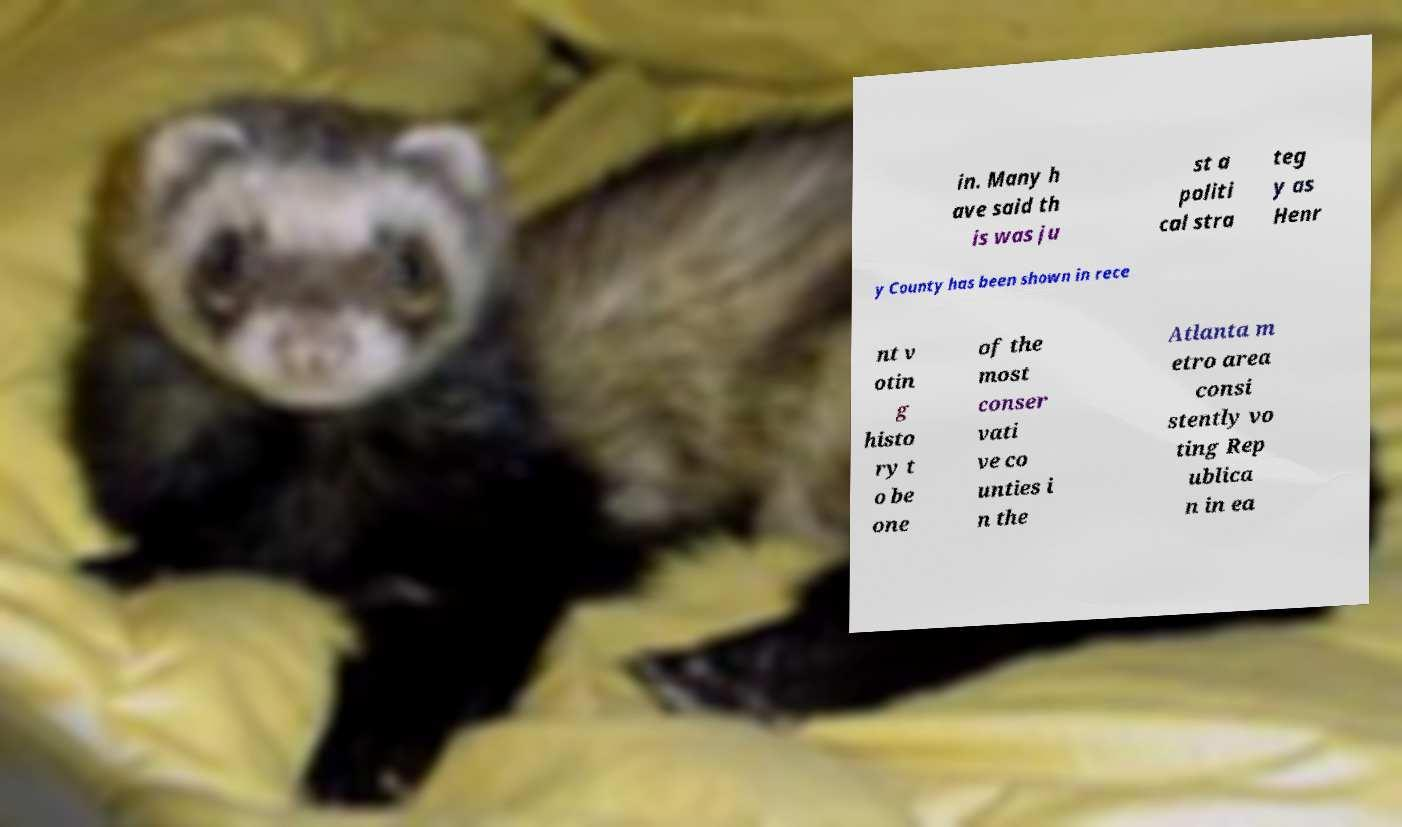There's text embedded in this image that I need extracted. Can you transcribe it verbatim? in. Many h ave said th is was ju st a politi cal stra teg y as Henr y County has been shown in rece nt v otin g histo ry t o be one of the most conser vati ve co unties i n the Atlanta m etro area consi stently vo ting Rep ublica n in ea 